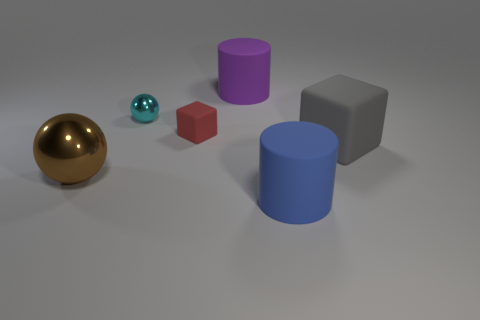Add 3 blue rubber balls. How many objects exist? 9 Subtract all blocks. How many objects are left? 4 Subtract 2 cylinders. How many cylinders are left? 0 Add 2 balls. How many balls exist? 4 Subtract all red blocks. How many blocks are left? 1 Subtract 0 purple spheres. How many objects are left? 6 Subtract all purple spheres. Subtract all blue cubes. How many spheres are left? 2 Subtract all big spheres. Subtract all cyan shiny objects. How many objects are left? 4 Add 6 big objects. How many big objects are left? 10 